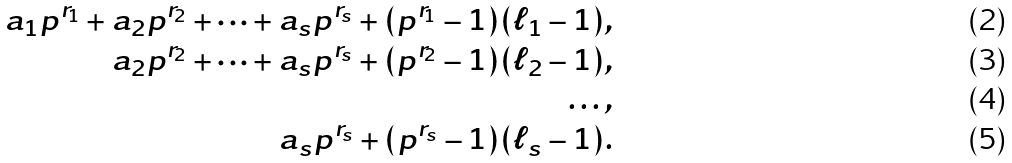Convert formula to latex. <formula><loc_0><loc_0><loc_500><loc_500>a _ { 1 } p ^ { r _ { 1 } } + a _ { 2 } p ^ { r _ { 2 } } + \dots + a _ { s } p ^ { r _ { s } } + ( p ^ { r _ { 1 } } - 1 ) ( \ell _ { 1 } - 1 ) , \\ a _ { 2 } p ^ { r _ { 2 } } + \dots + a _ { s } p ^ { r _ { s } } + ( p ^ { r _ { 2 } } - 1 ) ( \ell _ { 2 } - 1 ) , \\ \dots , \\ a _ { s } p ^ { r _ { s } } + ( p ^ { r _ { s } } - 1 ) ( \ell _ { s } - 1 ) .</formula> 